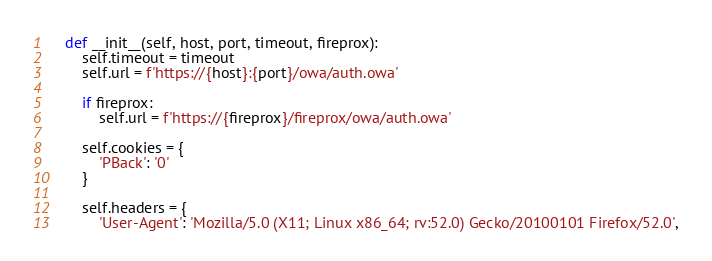<code> <loc_0><loc_0><loc_500><loc_500><_Python_>
    def __init__(self, host, port, timeout, fireprox):
        self.timeout = timeout
        self.url = f'https://{host}:{port}/owa/auth.owa'

        if fireprox:
            self.url = f'https://{fireprox}/fireprox/owa/auth.owa'

        self.cookies = {
            'PBack': '0'
        }

        self.headers = {
            'User-Agent': 'Mozilla/5.0 (X11; Linux x86_64; rv:52.0) Gecko/20100101 Firefox/52.0',</code> 